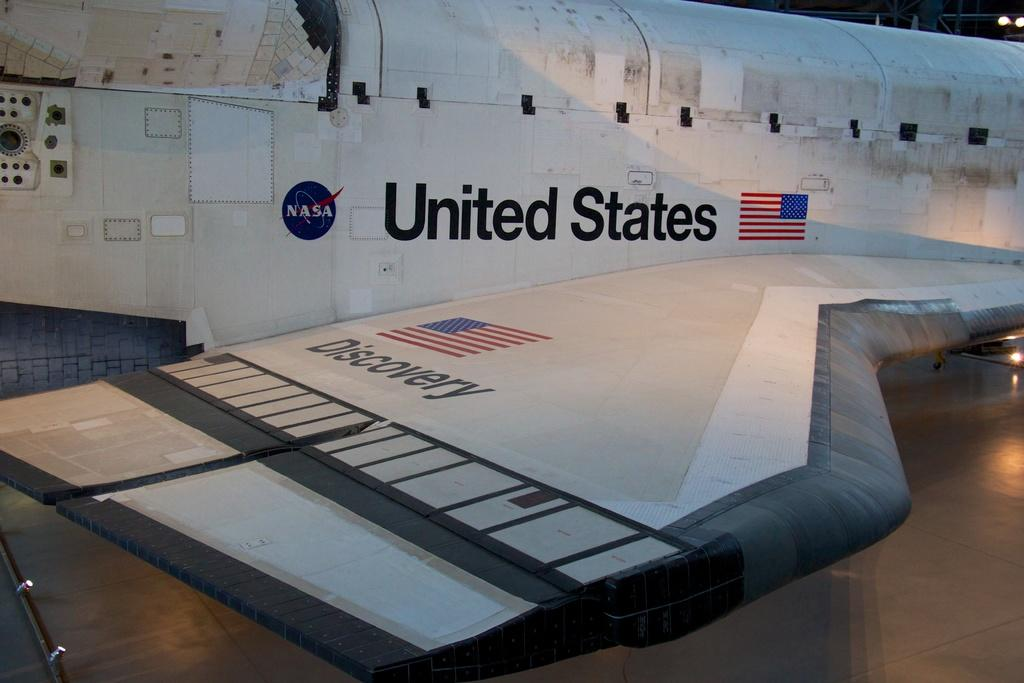<image>
Create a compact narrative representing the image presented. A United States NASA rocket has dust and debris on the body. 